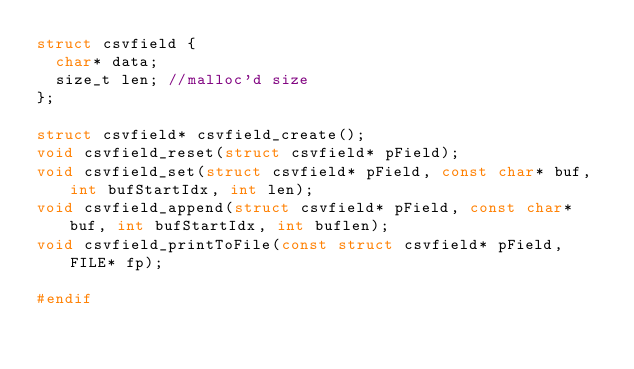<code> <loc_0><loc_0><loc_500><loc_500><_C_>struct csvfield {
  char* data;
  size_t len; //malloc'd size
};

struct csvfield* csvfield_create();
void csvfield_reset(struct csvfield* pField);
void csvfield_set(struct csvfield* pField, const char* buf, int bufStartIdx, int len);
void csvfield_append(struct csvfield* pField, const char* buf, int bufStartIdx, int buflen);
void csvfield_printToFile(const struct csvfield* pField, FILE* fp);

#endif
</code> 